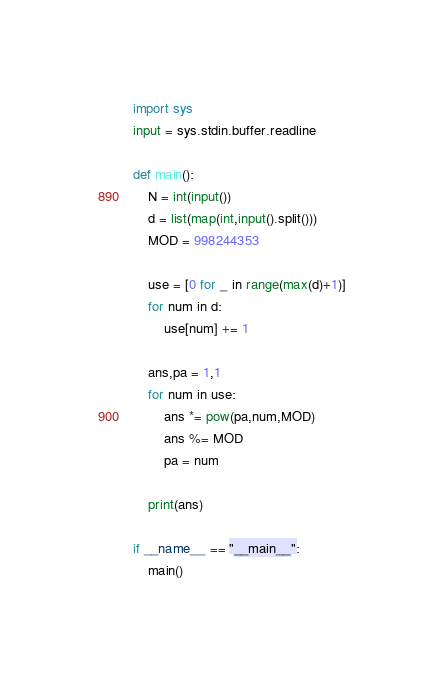Convert code to text. <code><loc_0><loc_0><loc_500><loc_500><_Python_>import sys
input = sys.stdin.buffer.readline

def main():
    N = int(input())
    d = list(map(int,input().split()))
    MOD = 998244353
    
    use = [0 for _ in range(max(d)+1)]
    for num in d:
        use[num] += 1
    
    ans,pa = 1,1
    for num in use:
        ans *= pow(pa,num,MOD)
        ans %= MOD
        pa = num
        
    print(ans)

if __name__ == "__main__":
    main()
</code> 